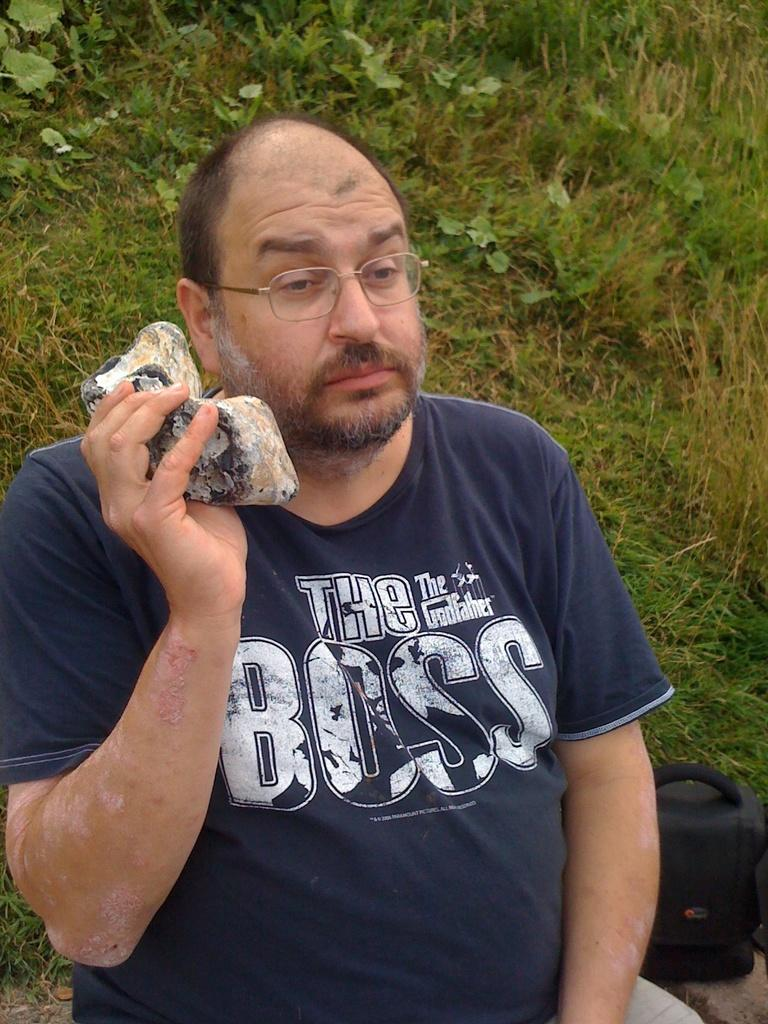Who is present in the image? There is a man in the image. What is the man holding in the image? The man is holding an object. What can be seen in the background of the image? There is grass in the background of the image. Where is the bag located in the image? There is a bag in the right bottom of the image. What type of fiction is the man reading in the image? There is no book or any form of reading material present in the image, so it cannot be determined if the man is reading fiction or any other type of content. 